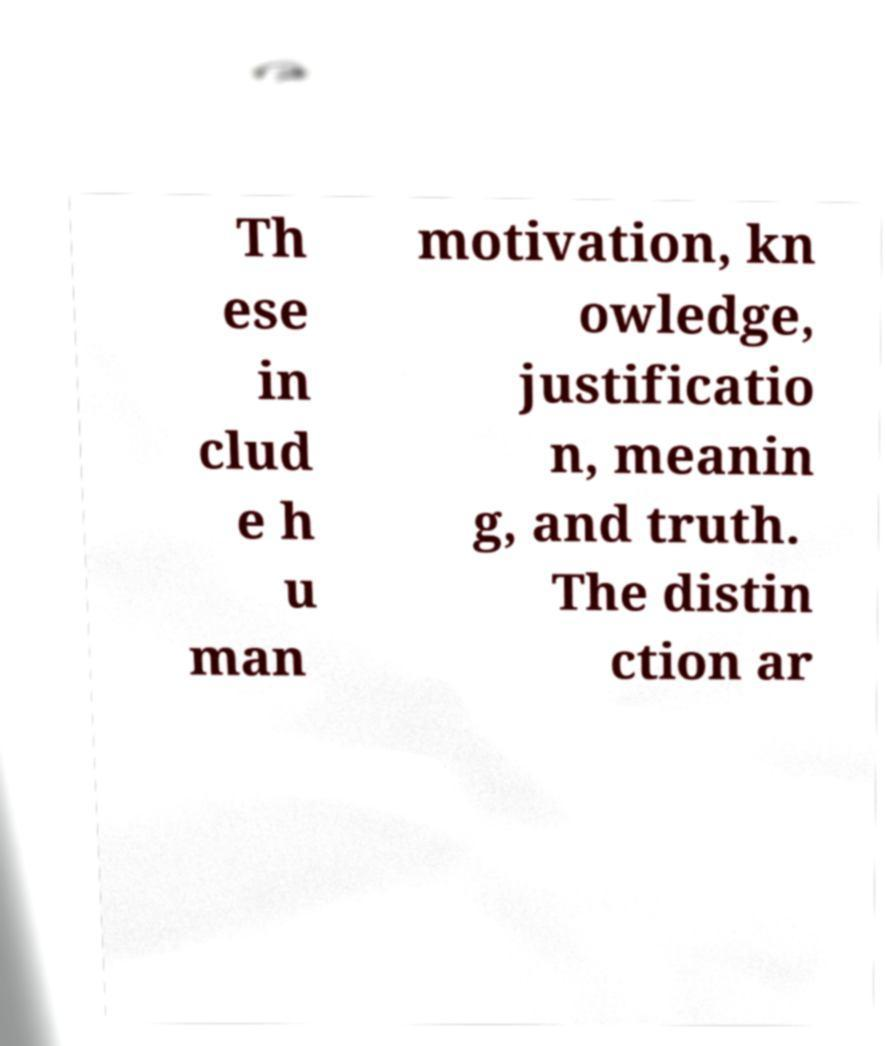Please identify and transcribe the text found in this image. Th ese in clud e h u man motivation, kn owledge, justificatio n, meanin g, and truth. The distin ction ar 